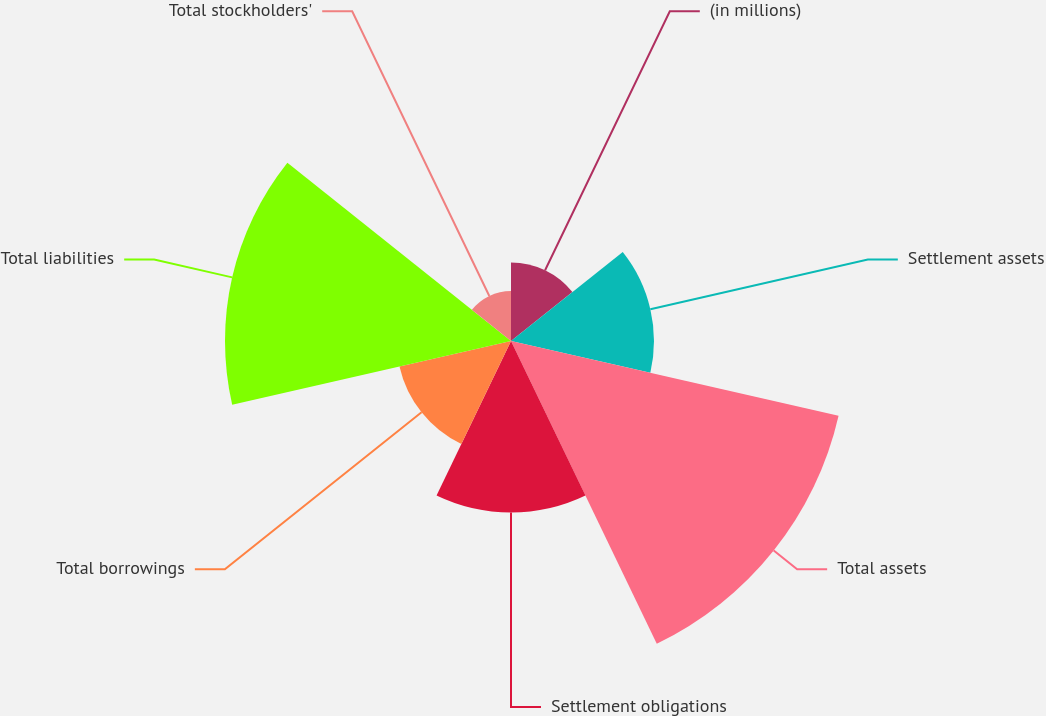Convert chart to OTSL. <chart><loc_0><loc_0><loc_500><loc_500><pie_chart><fcel>(in millions)<fcel>Settlement assets<fcel>Total assets<fcel>Settlement obligations<fcel>Total borrowings<fcel>Total liabilities<fcel>Total stockholders'<nl><fcel>6.66%<fcel>12.12%<fcel>28.49%<fcel>14.55%<fcel>9.7%<fcel>24.25%<fcel>4.24%<nl></chart> 